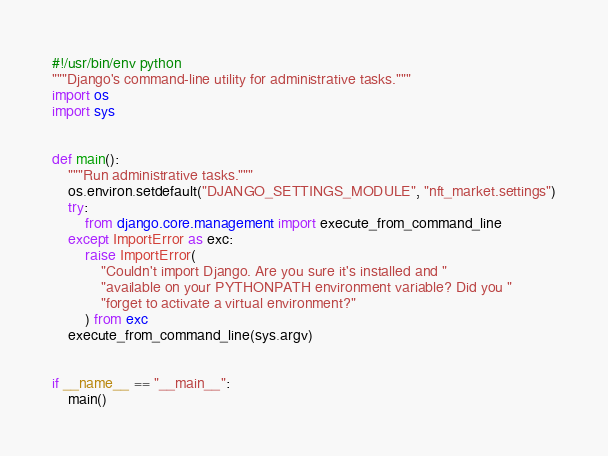<code> <loc_0><loc_0><loc_500><loc_500><_Python_>#!/usr/bin/env python
"""Django's command-line utility for administrative tasks."""
import os
import sys


def main():
    """Run administrative tasks."""
    os.environ.setdefault("DJANGO_SETTINGS_MODULE", "nft_market.settings")
    try:
        from django.core.management import execute_from_command_line
    except ImportError as exc:
        raise ImportError(
            "Couldn't import Django. Are you sure it's installed and "
            "available on your PYTHONPATH environment variable? Did you "
            "forget to activate a virtual environment?"
        ) from exc
    execute_from_command_line(sys.argv)


if __name__ == "__main__":
    main()
</code> 